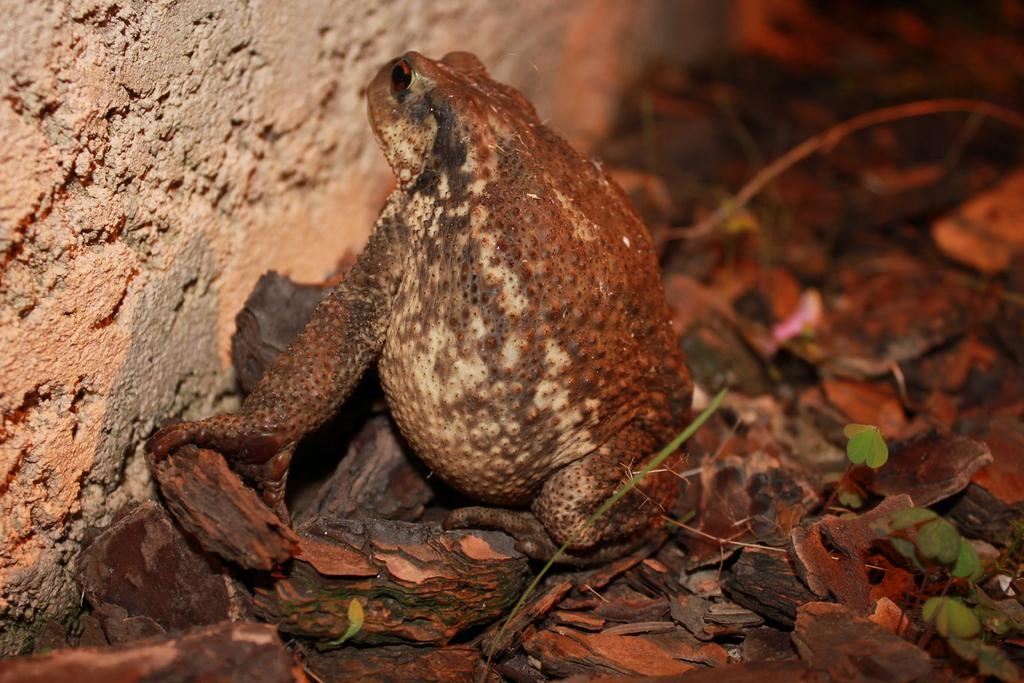What animal can be seen in the image? There is a frog in the image. Where is the frog located? The frog is on the ground. What else can be found on the ground in the image? There are wooden pieces and plants on the ground. Can you describe the area where the frog is located? There is a grassy area in the image. What is visible on the left side of the image? There is a wall on the left side of the image. How would you describe the background of the image? The background of the image is blurred. What type of toothpaste is the frog using in the image? There is no toothpaste present in the image, and the frog is not using any toothpaste. What word is written on the wall in the image? There are no words visible on the wall in the image. 